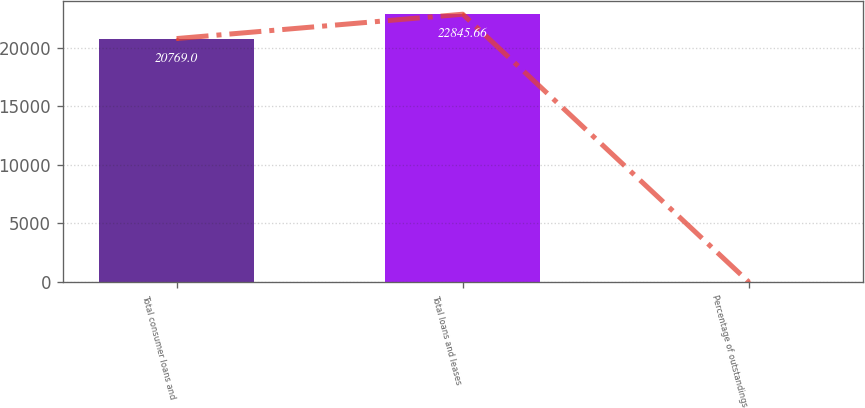Convert chart. <chart><loc_0><loc_0><loc_500><loc_500><bar_chart><fcel>Total consumer loans and<fcel>Total loans and leases<fcel>Percentage of outstandings<nl><fcel>20769<fcel>22845.7<fcel>2.36<nl></chart> 